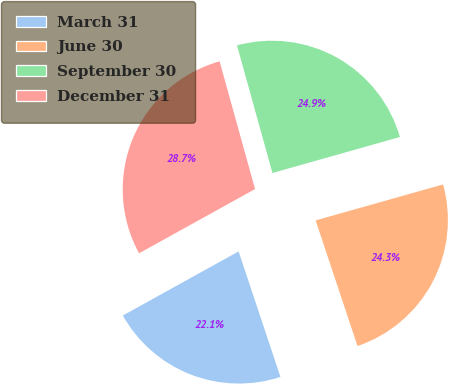Convert chart to OTSL. <chart><loc_0><loc_0><loc_500><loc_500><pie_chart><fcel>March 31<fcel>June 30<fcel>September 30<fcel>December 31<nl><fcel>22.07%<fcel>24.26%<fcel>24.93%<fcel>28.74%<nl></chart> 